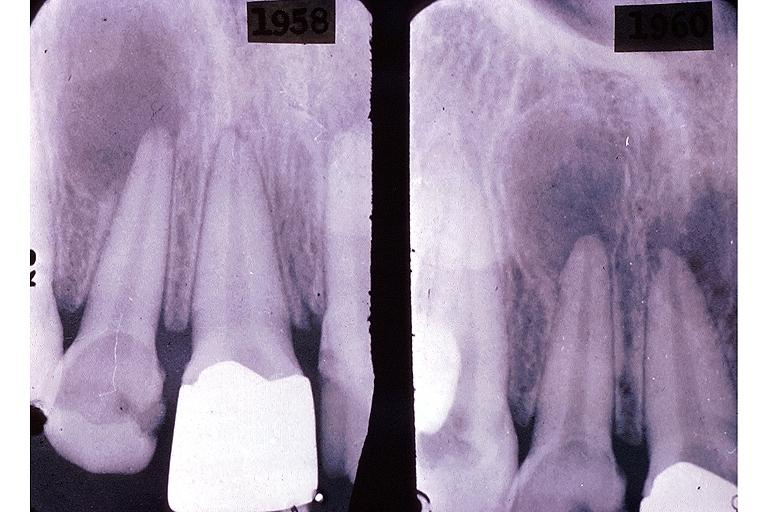where is this?
Answer the question using a single word or phrase. Oral 